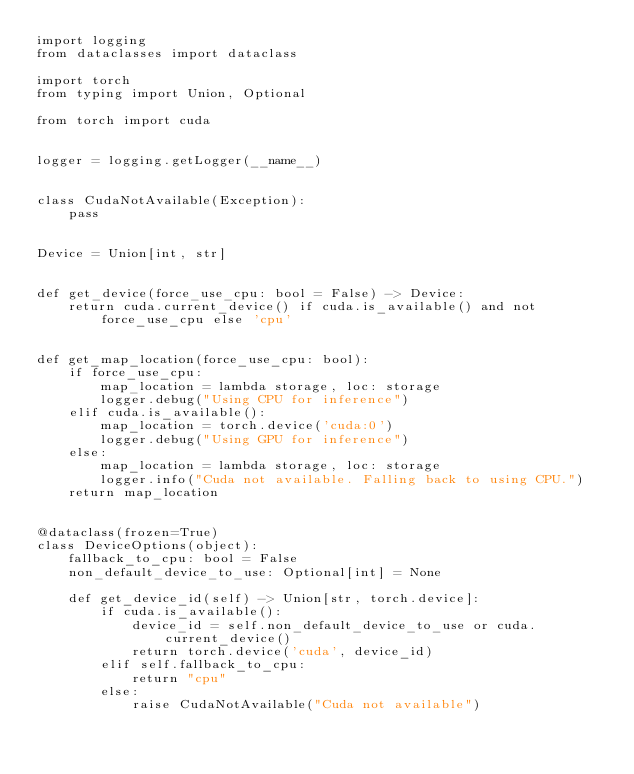Convert code to text. <code><loc_0><loc_0><loc_500><loc_500><_Python_>import logging
from dataclasses import dataclass

import torch
from typing import Union, Optional

from torch import cuda


logger = logging.getLogger(__name__)


class CudaNotAvailable(Exception):
    pass


Device = Union[int, str]


def get_device(force_use_cpu: bool = False) -> Device:
    return cuda.current_device() if cuda.is_available() and not force_use_cpu else 'cpu'


def get_map_location(force_use_cpu: bool):
    if force_use_cpu:
        map_location = lambda storage, loc: storage
        logger.debug("Using CPU for inference")
    elif cuda.is_available():
        map_location = torch.device('cuda:0')
        logger.debug("Using GPU for inference")
    else:
        map_location = lambda storage, loc: storage
        logger.info("Cuda not available. Falling back to using CPU.")
    return map_location


@dataclass(frozen=True)
class DeviceOptions(object):
    fallback_to_cpu: bool = False
    non_default_device_to_use: Optional[int] = None

    def get_device_id(self) -> Union[str, torch.device]:
        if cuda.is_available():
            device_id = self.non_default_device_to_use or cuda.current_device()
            return torch.device('cuda', device_id)
        elif self.fallback_to_cpu:
            return "cpu"
        else:
            raise CudaNotAvailable("Cuda not available")</code> 